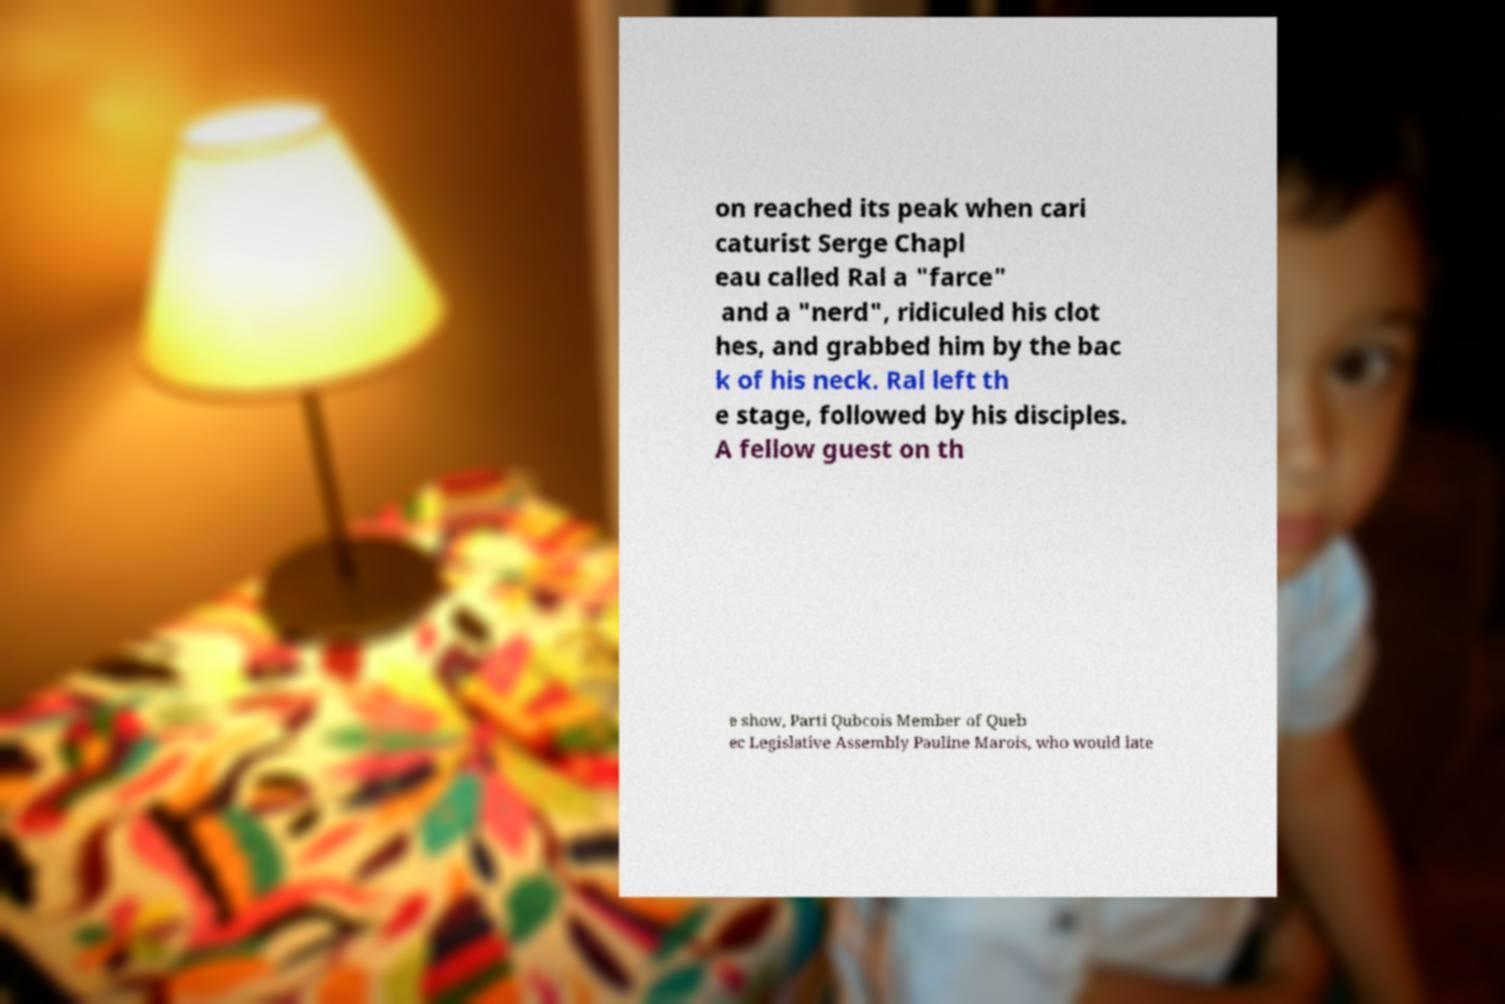Please identify and transcribe the text found in this image. on reached its peak when cari caturist Serge Chapl eau called Ral a "farce" and a "nerd", ridiculed his clot hes, and grabbed him by the bac k of his neck. Ral left th e stage, followed by his disciples. A fellow guest on th e show, Parti Qubcois Member of Queb ec Legislative Assembly Pauline Marois, who would late 